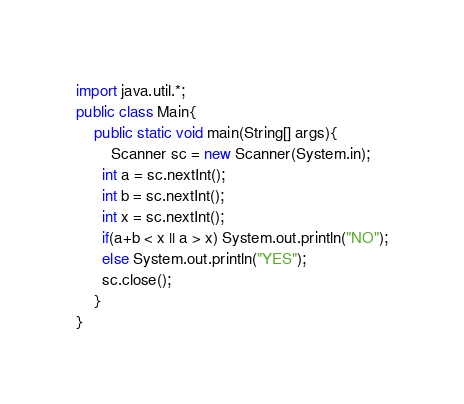<code> <loc_0><loc_0><loc_500><loc_500><_Java_>import java.util.*;
public class Main{
	public static void main(String[] args){
    	Scanner sc = new Scanner(System.in);
      int a = sc.nextInt();
      int b = sc.nextInt();
      int x = sc.nextInt();
      if(a+b < x || a > x) System.out.println("NO");
      else System.out.println("YES");
      sc.close();
    }
}
</code> 